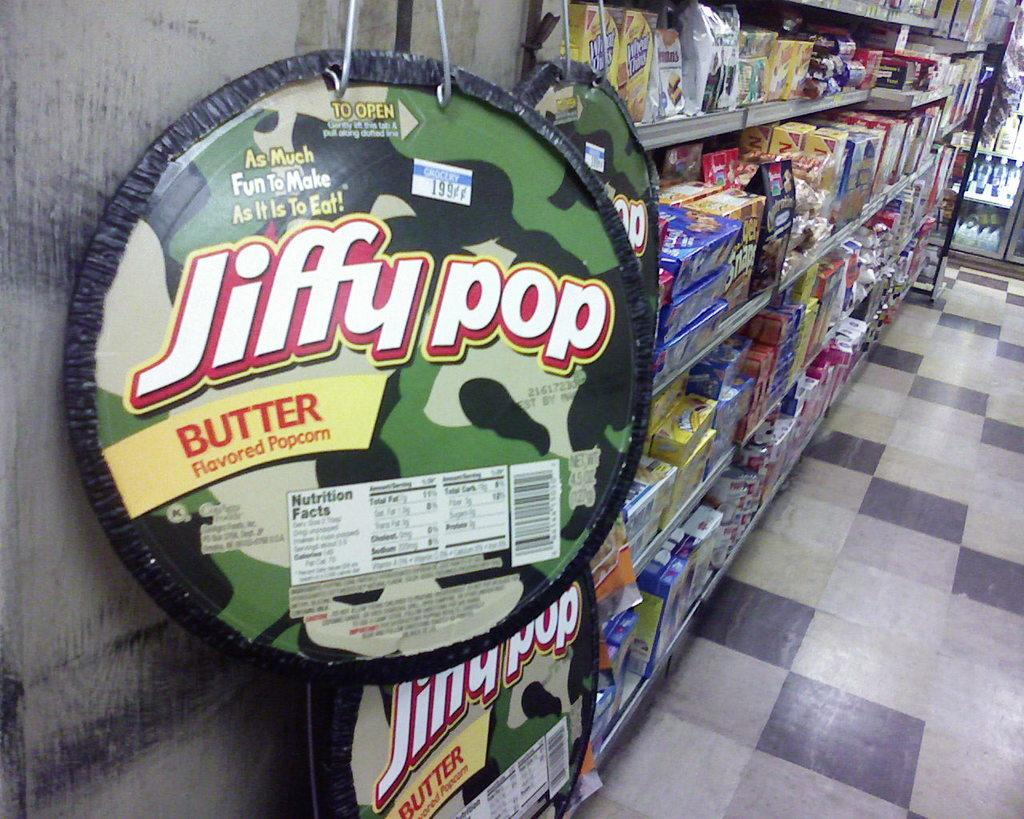<image>
Summarize the visual content of the image. A grocery aisle displaying Jiffy Pop Butter Flavored Popcorn 